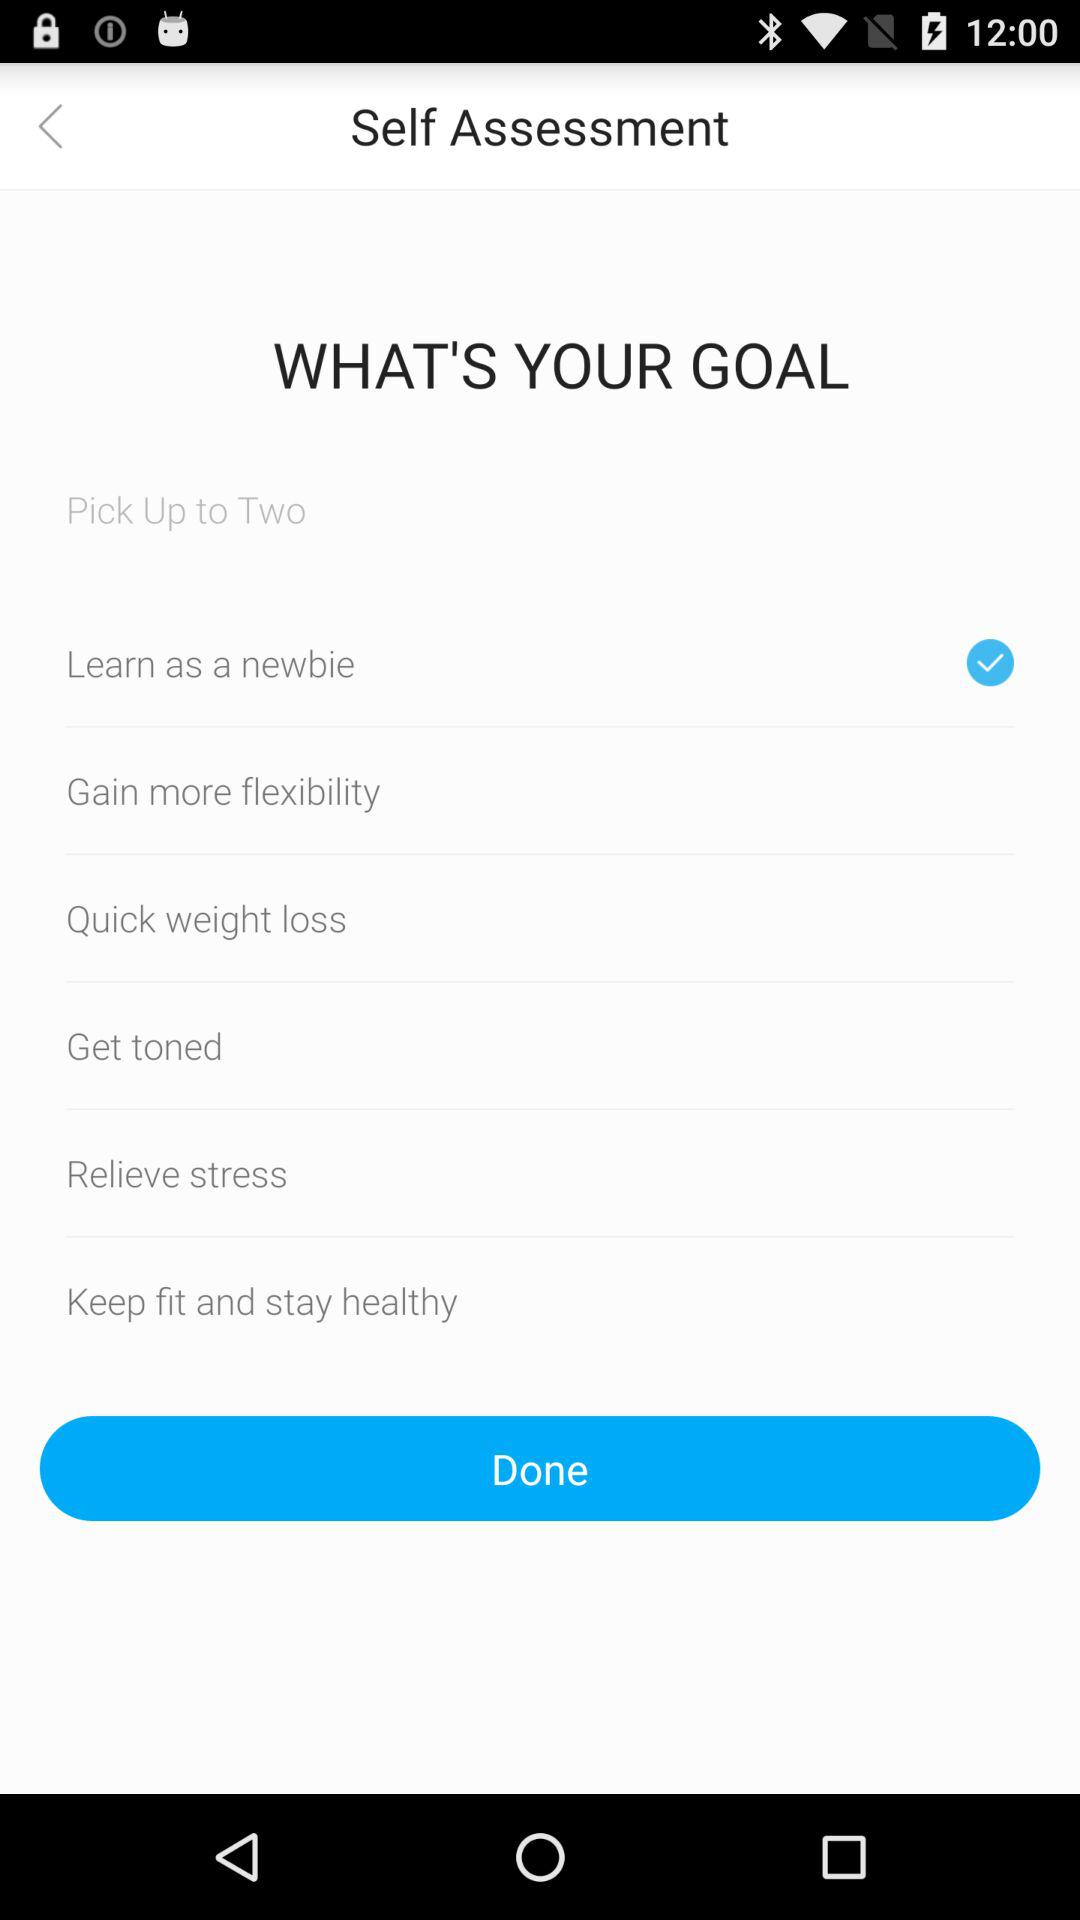What goal is selected? The selected goal is "Learn as a newbie". 